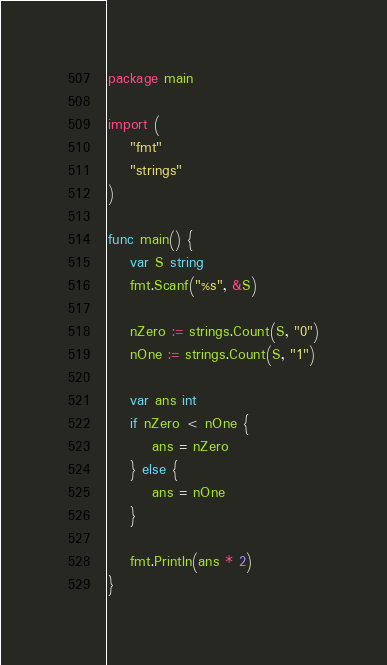<code> <loc_0><loc_0><loc_500><loc_500><_Go_>package main

import (
	"fmt"
	"strings"
)

func main() {
	var S string
	fmt.Scanf("%s", &S)

	nZero := strings.Count(S, "0")
	nOne := strings.Count(S, "1")

	var ans int
	if nZero < nOne {
		ans = nZero
	} else {
		ans = nOne
	}

	fmt.Println(ans * 2)
}</code> 